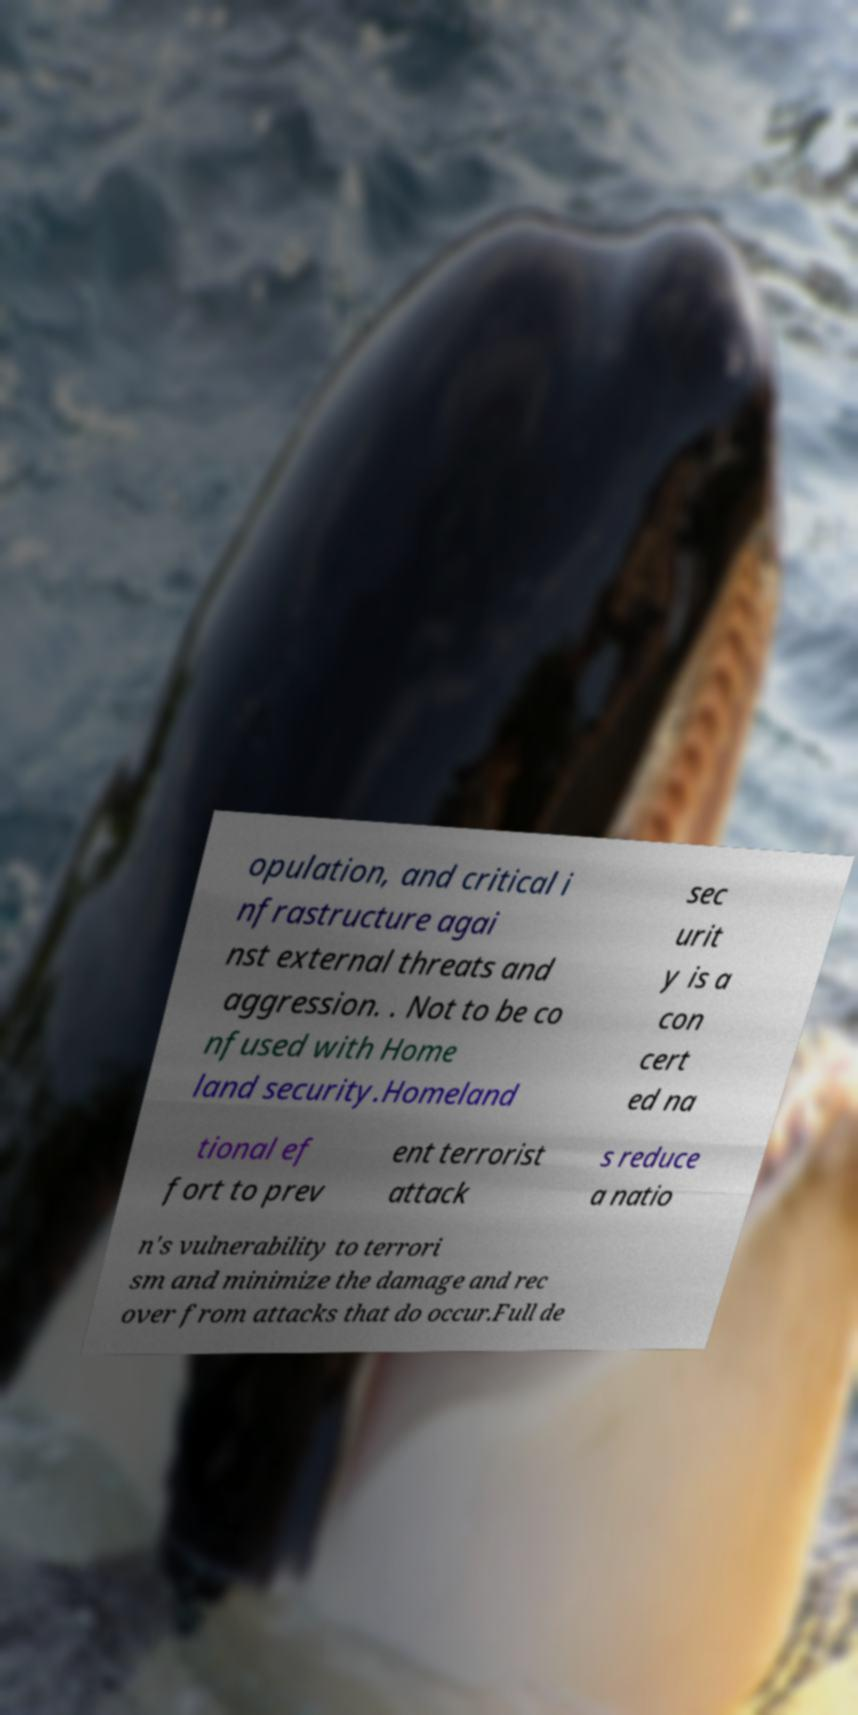Could you extract and type out the text from this image? opulation, and critical i nfrastructure agai nst external threats and aggression. . Not to be co nfused with Home land security.Homeland sec urit y is a con cert ed na tional ef fort to prev ent terrorist attack s reduce a natio n's vulnerability to terrori sm and minimize the damage and rec over from attacks that do occur.Full de 